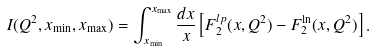<formula> <loc_0><loc_0><loc_500><loc_500>I ( Q ^ { 2 } , x _ { \min } , x _ { \max } ) = \int _ { x _ { \min } } ^ { x _ { \max } } \frac { d x } { x } \left [ F _ { 2 } ^ { l p } ( x , Q ^ { 2 } ) - F _ { 2 } ^ { \ln } ( x , Q ^ { 2 } ) \right ] .</formula> 